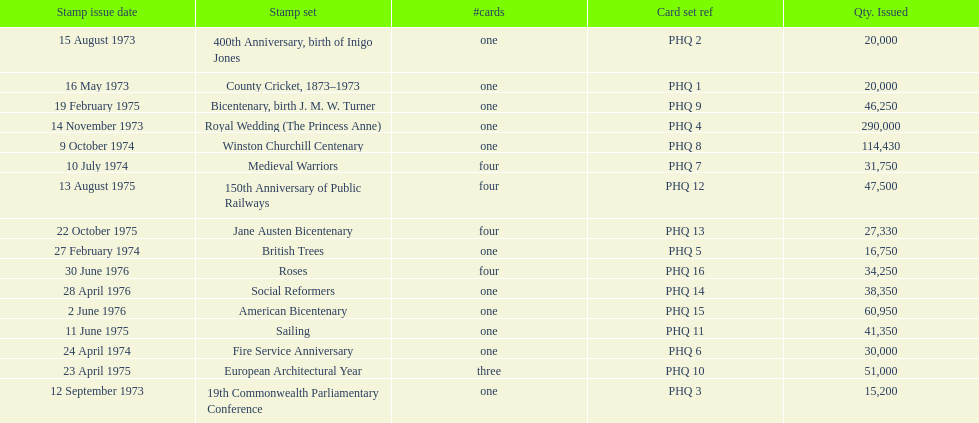Would you mind parsing the complete table? {'header': ['Stamp issue date', 'Stamp set', '#cards', 'Card set ref', 'Qty. Issued'], 'rows': [['15 August 1973', '400th Anniversary, birth of Inigo Jones', 'one', 'PHQ 2', '20,000'], ['16 May 1973', 'County Cricket, 1873–1973', 'one', 'PHQ 1', '20,000'], ['19 February 1975', 'Bicentenary, birth J. M. W. Turner', 'one', 'PHQ 9', '46,250'], ['14 November 1973', 'Royal Wedding (The Princess Anne)', 'one', 'PHQ 4', '290,000'], ['9 October 1974', 'Winston Churchill Centenary', 'one', 'PHQ 8', '114,430'], ['10 July 1974', 'Medieval Warriors', 'four', 'PHQ 7', '31,750'], ['13 August 1975', '150th Anniversary of Public Railways', 'four', 'PHQ 12', '47,500'], ['22 October 1975', 'Jane Austen Bicentenary', 'four', 'PHQ 13', '27,330'], ['27 February 1974', 'British Trees', 'one', 'PHQ 5', '16,750'], ['30 June 1976', 'Roses', 'four', 'PHQ 16', '34,250'], ['28 April 1976', 'Social Reformers', 'one', 'PHQ 14', '38,350'], ['2 June 1976', 'American Bicentenary', 'one', 'PHQ 15', '60,950'], ['11 June 1975', 'Sailing', 'one', 'PHQ 11', '41,350'], ['24 April 1974', 'Fire Service Anniversary', 'one', 'PHQ 6', '30,000'], ['23 April 1975', 'European Architectural Year', 'three', 'PHQ 10', '51,000'], ['12 September 1973', '19th Commonwealth Parliamentary Conference', 'one', 'PHQ 3', '15,200']]} How many stamp sets were released in the year 1975? 5. 